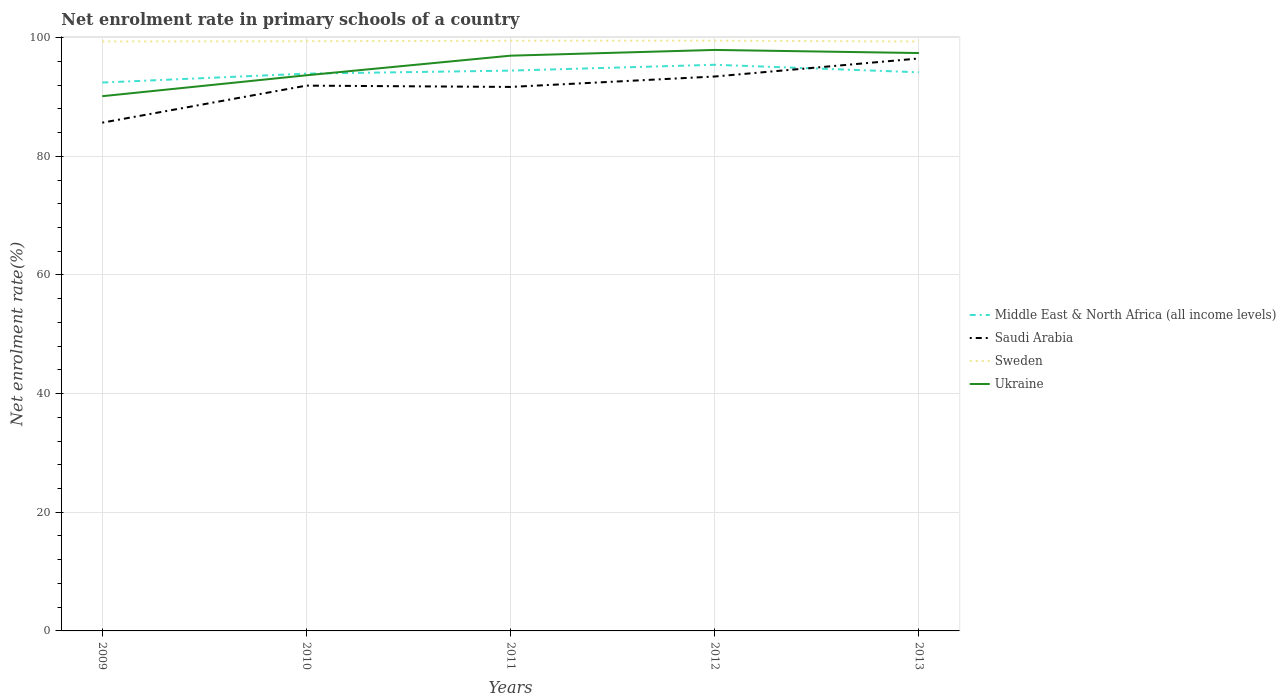Is the number of lines equal to the number of legend labels?
Provide a succinct answer. Yes. Across all years, what is the maximum net enrolment rate in primary schools in Sweden?
Your response must be concise. 99.34. What is the total net enrolment rate in primary schools in Sweden in the graph?
Make the answer very short. 0.01. What is the difference between the highest and the second highest net enrolment rate in primary schools in Middle East & North Africa (all income levels)?
Offer a very short reply. 3. What is the difference between the highest and the lowest net enrolment rate in primary schools in Ukraine?
Your answer should be compact. 3. How many lines are there?
Your response must be concise. 4. How many years are there in the graph?
Offer a terse response. 5. Does the graph contain any zero values?
Offer a terse response. No. How many legend labels are there?
Keep it short and to the point. 4. How are the legend labels stacked?
Make the answer very short. Vertical. What is the title of the graph?
Ensure brevity in your answer.  Net enrolment rate in primary schools of a country. What is the label or title of the Y-axis?
Give a very brief answer. Net enrolment rate(%). What is the Net enrolment rate(%) in Middle East & North Africa (all income levels) in 2009?
Make the answer very short. 92.43. What is the Net enrolment rate(%) of Saudi Arabia in 2009?
Your response must be concise. 85.67. What is the Net enrolment rate(%) of Sweden in 2009?
Offer a terse response. 99.35. What is the Net enrolment rate(%) in Ukraine in 2009?
Offer a terse response. 90.13. What is the Net enrolment rate(%) of Middle East & North Africa (all income levels) in 2010?
Provide a short and direct response. 93.93. What is the Net enrolment rate(%) of Saudi Arabia in 2010?
Your answer should be compact. 91.91. What is the Net enrolment rate(%) in Sweden in 2010?
Ensure brevity in your answer.  99.4. What is the Net enrolment rate(%) of Ukraine in 2010?
Your response must be concise. 93.65. What is the Net enrolment rate(%) of Middle East & North Africa (all income levels) in 2011?
Ensure brevity in your answer.  94.44. What is the Net enrolment rate(%) in Saudi Arabia in 2011?
Your answer should be compact. 91.69. What is the Net enrolment rate(%) of Sweden in 2011?
Make the answer very short. 99.47. What is the Net enrolment rate(%) of Ukraine in 2011?
Give a very brief answer. 96.96. What is the Net enrolment rate(%) of Middle East & North Africa (all income levels) in 2012?
Your answer should be very brief. 95.43. What is the Net enrolment rate(%) of Saudi Arabia in 2012?
Give a very brief answer. 93.45. What is the Net enrolment rate(%) in Sweden in 2012?
Ensure brevity in your answer.  99.49. What is the Net enrolment rate(%) in Ukraine in 2012?
Your answer should be compact. 97.93. What is the Net enrolment rate(%) of Middle East & North Africa (all income levels) in 2013?
Your response must be concise. 94.16. What is the Net enrolment rate(%) of Saudi Arabia in 2013?
Your answer should be compact. 96.49. What is the Net enrolment rate(%) of Sweden in 2013?
Offer a very short reply. 99.34. What is the Net enrolment rate(%) in Ukraine in 2013?
Give a very brief answer. 97.4. Across all years, what is the maximum Net enrolment rate(%) in Middle East & North Africa (all income levels)?
Your answer should be compact. 95.43. Across all years, what is the maximum Net enrolment rate(%) in Saudi Arabia?
Offer a very short reply. 96.49. Across all years, what is the maximum Net enrolment rate(%) of Sweden?
Provide a succinct answer. 99.49. Across all years, what is the maximum Net enrolment rate(%) of Ukraine?
Provide a short and direct response. 97.93. Across all years, what is the minimum Net enrolment rate(%) in Middle East & North Africa (all income levels)?
Offer a very short reply. 92.43. Across all years, what is the minimum Net enrolment rate(%) in Saudi Arabia?
Ensure brevity in your answer.  85.67. Across all years, what is the minimum Net enrolment rate(%) in Sweden?
Offer a very short reply. 99.34. Across all years, what is the minimum Net enrolment rate(%) of Ukraine?
Provide a succinct answer. 90.13. What is the total Net enrolment rate(%) in Middle East & North Africa (all income levels) in the graph?
Ensure brevity in your answer.  470.39. What is the total Net enrolment rate(%) of Saudi Arabia in the graph?
Keep it short and to the point. 459.2. What is the total Net enrolment rate(%) in Sweden in the graph?
Provide a succinct answer. 497.05. What is the total Net enrolment rate(%) in Ukraine in the graph?
Your answer should be compact. 476.07. What is the difference between the Net enrolment rate(%) in Middle East & North Africa (all income levels) in 2009 and that in 2010?
Give a very brief answer. -1.5. What is the difference between the Net enrolment rate(%) of Saudi Arabia in 2009 and that in 2010?
Give a very brief answer. -6.24. What is the difference between the Net enrolment rate(%) of Sweden in 2009 and that in 2010?
Ensure brevity in your answer.  -0.05. What is the difference between the Net enrolment rate(%) in Ukraine in 2009 and that in 2010?
Your answer should be compact. -3.52. What is the difference between the Net enrolment rate(%) of Middle East & North Africa (all income levels) in 2009 and that in 2011?
Ensure brevity in your answer.  -2.01. What is the difference between the Net enrolment rate(%) of Saudi Arabia in 2009 and that in 2011?
Give a very brief answer. -6.02. What is the difference between the Net enrolment rate(%) of Sweden in 2009 and that in 2011?
Keep it short and to the point. -0.12. What is the difference between the Net enrolment rate(%) of Ukraine in 2009 and that in 2011?
Your response must be concise. -6.83. What is the difference between the Net enrolment rate(%) in Middle East & North Africa (all income levels) in 2009 and that in 2012?
Give a very brief answer. -3. What is the difference between the Net enrolment rate(%) in Saudi Arabia in 2009 and that in 2012?
Offer a terse response. -7.78. What is the difference between the Net enrolment rate(%) in Sweden in 2009 and that in 2012?
Your answer should be compact. -0.14. What is the difference between the Net enrolment rate(%) in Ukraine in 2009 and that in 2012?
Offer a terse response. -7.8. What is the difference between the Net enrolment rate(%) in Middle East & North Africa (all income levels) in 2009 and that in 2013?
Give a very brief answer. -1.73. What is the difference between the Net enrolment rate(%) of Saudi Arabia in 2009 and that in 2013?
Your answer should be compact. -10.82. What is the difference between the Net enrolment rate(%) in Sweden in 2009 and that in 2013?
Make the answer very short. 0.01. What is the difference between the Net enrolment rate(%) of Ukraine in 2009 and that in 2013?
Your answer should be compact. -7.27. What is the difference between the Net enrolment rate(%) in Middle East & North Africa (all income levels) in 2010 and that in 2011?
Your answer should be very brief. -0.51. What is the difference between the Net enrolment rate(%) of Saudi Arabia in 2010 and that in 2011?
Make the answer very short. 0.22. What is the difference between the Net enrolment rate(%) of Sweden in 2010 and that in 2011?
Your answer should be compact. -0.08. What is the difference between the Net enrolment rate(%) in Ukraine in 2010 and that in 2011?
Offer a terse response. -3.3. What is the difference between the Net enrolment rate(%) in Middle East & North Africa (all income levels) in 2010 and that in 2012?
Ensure brevity in your answer.  -1.49. What is the difference between the Net enrolment rate(%) of Saudi Arabia in 2010 and that in 2012?
Your answer should be very brief. -1.54. What is the difference between the Net enrolment rate(%) in Sweden in 2010 and that in 2012?
Provide a short and direct response. -0.09. What is the difference between the Net enrolment rate(%) in Ukraine in 2010 and that in 2012?
Offer a terse response. -4.27. What is the difference between the Net enrolment rate(%) in Middle East & North Africa (all income levels) in 2010 and that in 2013?
Ensure brevity in your answer.  -0.23. What is the difference between the Net enrolment rate(%) in Saudi Arabia in 2010 and that in 2013?
Offer a very short reply. -4.58. What is the difference between the Net enrolment rate(%) of Sweden in 2010 and that in 2013?
Your answer should be compact. 0.05. What is the difference between the Net enrolment rate(%) of Ukraine in 2010 and that in 2013?
Your response must be concise. -3.75. What is the difference between the Net enrolment rate(%) of Middle East & North Africa (all income levels) in 2011 and that in 2012?
Your answer should be compact. -0.98. What is the difference between the Net enrolment rate(%) of Saudi Arabia in 2011 and that in 2012?
Provide a succinct answer. -1.76. What is the difference between the Net enrolment rate(%) of Sweden in 2011 and that in 2012?
Make the answer very short. -0.01. What is the difference between the Net enrolment rate(%) of Ukraine in 2011 and that in 2012?
Make the answer very short. -0.97. What is the difference between the Net enrolment rate(%) of Middle East & North Africa (all income levels) in 2011 and that in 2013?
Your answer should be very brief. 0.28. What is the difference between the Net enrolment rate(%) of Saudi Arabia in 2011 and that in 2013?
Keep it short and to the point. -4.8. What is the difference between the Net enrolment rate(%) of Sweden in 2011 and that in 2013?
Your answer should be compact. 0.13. What is the difference between the Net enrolment rate(%) in Ukraine in 2011 and that in 2013?
Make the answer very short. -0.44. What is the difference between the Net enrolment rate(%) of Middle East & North Africa (all income levels) in 2012 and that in 2013?
Give a very brief answer. 1.27. What is the difference between the Net enrolment rate(%) of Saudi Arabia in 2012 and that in 2013?
Your answer should be compact. -3.04. What is the difference between the Net enrolment rate(%) in Sweden in 2012 and that in 2013?
Your response must be concise. 0.14. What is the difference between the Net enrolment rate(%) of Ukraine in 2012 and that in 2013?
Your answer should be very brief. 0.52. What is the difference between the Net enrolment rate(%) of Middle East & North Africa (all income levels) in 2009 and the Net enrolment rate(%) of Saudi Arabia in 2010?
Offer a very short reply. 0.52. What is the difference between the Net enrolment rate(%) of Middle East & North Africa (all income levels) in 2009 and the Net enrolment rate(%) of Sweden in 2010?
Provide a succinct answer. -6.97. What is the difference between the Net enrolment rate(%) in Middle East & North Africa (all income levels) in 2009 and the Net enrolment rate(%) in Ukraine in 2010?
Provide a short and direct response. -1.23. What is the difference between the Net enrolment rate(%) in Saudi Arabia in 2009 and the Net enrolment rate(%) in Sweden in 2010?
Make the answer very short. -13.73. What is the difference between the Net enrolment rate(%) in Saudi Arabia in 2009 and the Net enrolment rate(%) in Ukraine in 2010?
Your response must be concise. -7.99. What is the difference between the Net enrolment rate(%) in Sweden in 2009 and the Net enrolment rate(%) in Ukraine in 2010?
Ensure brevity in your answer.  5.7. What is the difference between the Net enrolment rate(%) of Middle East & North Africa (all income levels) in 2009 and the Net enrolment rate(%) of Saudi Arabia in 2011?
Your answer should be compact. 0.74. What is the difference between the Net enrolment rate(%) in Middle East & North Africa (all income levels) in 2009 and the Net enrolment rate(%) in Sweden in 2011?
Provide a short and direct response. -7.04. What is the difference between the Net enrolment rate(%) in Middle East & North Africa (all income levels) in 2009 and the Net enrolment rate(%) in Ukraine in 2011?
Keep it short and to the point. -4.53. What is the difference between the Net enrolment rate(%) in Saudi Arabia in 2009 and the Net enrolment rate(%) in Sweden in 2011?
Offer a very short reply. -13.81. What is the difference between the Net enrolment rate(%) of Saudi Arabia in 2009 and the Net enrolment rate(%) of Ukraine in 2011?
Provide a succinct answer. -11.29. What is the difference between the Net enrolment rate(%) in Sweden in 2009 and the Net enrolment rate(%) in Ukraine in 2011?
Make the answer very short. 2.39. What is the difference between the Net enrolment rate(%) in Middle East & North Africa (all income levels) in 2009 and the Net enrolment rate(%) in Saudi Arabia in 2012?
Your answer should be very brief. -1.02. What is the difference between the Net enrolment rate(%) of Middle East & North Africa (all income levels) in 2009 and the Net enrolment rate(%) of Sweden in 2012?
Your response must be concise. -7.06. What is the difference between the Net enrolment rate(%) in Middle East & North Africa (all income levels) in 2009 and the Net enrolment rate(%) in Ukraine in 2012?
Give a very brief answer. -5.5. What is the difference between the Net enrolment rate(%) of Saudi Arabia in 2009 and the Net enrolment rate(%) of Sweden in 2012?
Keep it short and to the point. -13.82. What is the difference between the Net enrolment rate(%) of Saudi Arabia in 2009 and the Net enrolment rate(%) of Ukraine in 2012?
Ensure brevity in your answer.  -12.26. What is the difference between the Net enrolment rate(%) in Sweden in 2009 and the Net enrolment rate(%) in Ukraine in 2012?
Keep it short and to the point. 1.42. What is the difference between the Net enrolment rate(%) in Middle East & North Africa (all income levels) in 2009 and the Net enrolment rate(%) in Saudi Arabia in 2013?
Make the answer very short. -4.06. What is the difference between the Net enrolment rate(%) in Middle East & North Africa (all income levels) in 2009 and the Net enrolment rate(%) in Sweden in 2013?
Keep it short and to the point. -6.92. What is the difference between the Net enrolment rate(%) of Middle East & North Africa (all income levels) in 2009 and the Net enrolment rate(%) of Ukraine in 2013?
Offer a terse response. -4.97. What is the difference between the Net enrolment rate(%) of Saudi Arabia in 2009 and the Net enrolment rate(%) of Sweden in 2013?
Offer a very short reply. -13.68. What is the difference between the Net enrolment rate(%) of Saudi Arabia in 2009 and the Net enrolment rate(%) of Ukraine in 2013?
Your answer should be compact. -11.74. What is the difference between the Net enrolment rate(%) in Sweden in 2009 and the Net enrolment rate(%) in Ukraine in 2013?
Your response must be concise. 1.95. What is the difference between the Net enrolment rate(%) in Middle East & North Africa (all income levels) in 2010 and the Net enrolment rate(%) in Saudi Arabia in 2011?
Offer a very short reply. 2.24. What is the difference between the Net enrolment rate(%) in Middle East & North Africa (all income levels) in 2010 and the Net enrolment rate(%) in Sweden in 2011?
Provide a succinct answer. -5.54. What is the difference between the Net enrolment rate(%) of Middle East & North Africa (all income levels) in 2010 and the Net enrolment rate(%) of Ukraine in 2011?
Keep it short and to the point. -3.03. What is the difference between the Net enrolment rate(%) in Saudi Arabia in 2010 and the Net enrolment rate(%) in Sweden in 2011?
Your response must be concise. -7.56. What is the difference between the Net enrolment rate(%) in Saudi Arabia in 2010 and the Net enrolment rate(%) in Ukraine in 2011?
Your answer should be very brief. -5.05. What is the difference between the Net enrolment rate(%) in Sweden in 2010 and the Net enrolment rate(%) in Ukraine in 2011?
Make the answer very short. 2.44. What is the difference between the Net enrolment rate(%) of Middle East & North Africa (all income levels) in 2010 and the Net enrolment rate(%) of Saudi Arabia in 2012?
Offer a terse response. 0.49. What is the difference between the Net enrolment rate(%) of Middle East & North Africa (all income levels) in 2010 and the Net enrolment rate(%) of Sweden in 2012?
Your answer should be compact. -5.55. What is the difference between the Net enrolment rate(%) of Middle East & North Africa (all income levels) in 2010 and the Net enrolment rate(%) of Ukraine in 2012?
Provide a short and direct response. -3.99. What is the difference between the Net enrolment rate(%) of Saudi Arabia in 2010 and the Net enrolment rate(%) of Sweden in 2012?
Give a very brief answer. -7.58. What is the difference between the Net enrolment rate(%) of Saudi Arabia in 2010 and the Net enrolment rate(%) of Ukraine in 2012?
Make the answer very short. -6.02. What is the difference between the Net enrolment rate(%) in Sweden in 2010 and the Net enrolment rate(%) in Ukraine in 2012?
Make the answer very short. 1.47. What is the difference between the Net enrolment rate(%) in Middle East & North Africa (all income levels) in 2010 and the Net enrolment rate(%) in Saudi Arabia in 2013?
Keep it short and to the point. -2.55. What is the difference between the Net enrolment rate(%) in Middle East & North Africa (all income levels) in 2010 and the Net enrolment rate(%) in Sweden in 2013?
Provide a short and direct response. -5.41. What is the difference between the Net enrolment rate(%) in Middle East & North Africa (all income levels) in 2010 and the Net enrolment rate(%) in Ukraine in 2013?
Provide a succinct answer. -3.47. What is the difference between the Net enrolment rate(%) in Saudi Arabia in 2010 and the Net enrolment rate(%) in Sweden in 2013?
Provide a succinct answer. -7.43. What is the difference between the Net enrolment rate(%) of Saudi Arabia in 2010 and the Net enrolment rate(%) of Ukraine in 2013?
Provide a succinct answer. -5.49. What is the difference between the Net enrolment rate(%) in Sweden in 2010 and the Net enrolment rate(%) in Ukraine in 2013?
Provide a short and direct response. 1.99. What is the difference between the Net enrolment rate(%) in Middle East & North Africa (all income levels) in 2011 and the Net enrolment rate(%) in Sweden in 2012?
Give a very brief answer. -5.05. What is the difference between the Net enrolment rate(%) of Middle East & North Africa (all income levels) in 2011 and the Net enrolment rate(%) of Ukraine in 2012?
Provide a succinct answer. -3.48. What is the difference between the Net enrolment rate(%) of Saudi Arabia in 2011 and the Net enrolment rate(%) of Sweden in 2012?
Your answer should be very brief. -7.8. What is the difference between the Net enrolment rate(%) of Saudi Arabia in 2011 and the Net enrolment rate(%) of Ukraine in 2012?
Offer a terse response. -6.24. What is the difference between the Net enrolment rate(%) of Sweden in 2011 and the Net enrolment rate(%) of Ukraine in 2012?
Give a very brief answer. 1.55. What is the difference between the Net enrolment rate(%) of Middle East & North Africa (all income levels) in 2011 and the Net enrolment rate(%) of Saudi Arabia in 2013?
Your answer should be very brief. -2.04. What is the difference between the Net enrolment rate(%) of Middle East & North Africa (all income levels) in 2011 and the Net enrolment rate(%) of Sweden in 2013?
Ensure brevity in your answer.  -4.9. What is the difference between the Net enrolment rate(%) in Middle East & North Africa (all income levels) in 2011 and the Net enrolment rate(%) in Ukraine in 2013?
Offer a very short reply. -2.96. What is the difference between the Net enrolment rate(%) in Saudi Arabia in 2011 and the Net enrolment rate(%) in Sweden in 2013?
Provide a short and direct response. -7.65. What is the difference between the Net enrolment rate(%) in Saudi Arabia in 2011 and the Net enrolment rate(%) in Ukraine in 2013?
Keep it short and to the point. -5.71. What is the difference between the Net enrolment rate(%) of Sweden in 2011 and the Net enrolment rate(%) of Ukraine in 2013?
Your response must be concise. 2.07. What is the difference between the Net enrolment rate(%) in Middle East & North Africa (all income levels) in 2012 and the Net enrolment rate(%) in Saudi Arabia in 2013?
Offer a very short reply. -1.06. What is the difference between the Net enrolment rate(%) in Middle East & North Africa (all income levels) in 2012 and the Net enrolment rate(%) in Sweden in 2013?
Your answer should be compact. -3.92. What is the difference between the Net enrolment rate(%) in Middle East & North Africa (all income levels) in 2012 and the Net enrolment rate(%) in Ukraine in 2013?
Ensure brevity in your answer.  -1.98. What is the difference between the Net enrolment rate(%) in Saudi Arabia in 2012 and the Net enrolment rate(%) in Sweden in 2013?
Offer a very short reply. -5.9. What is the difference between the Net enrolment rate(%) in Saudi Arabia in 2012 and the Net enrolment rate(%) in Ukraine in 2013?
Keep it short and to the point. -3.96. What is the difference between the Net enrolment rate(%) of Sweden in 2012 and the Net enrolment rate(%) of Ukraine in 2013?
Ensure brevity in your answer.  2.08. What is the average Net enrolment rate(%) in Middle East & North Africa (all income levels) per year?
Keep it short and to the point. 94.08. What is the average Net enrolment rate(%) of Saudi Arabia per year?
Keep it short and to the point. 91.84. What is the average Net enrolment rate(%) in Sweden per year?
Offer a very short reply. 99.41. What is the average Net enrolment rate(%) of Ukraine per year?
Offer a terse response. 95.21. In the year 2009, what is the difference between the Net enrolment rate(%) in Middle East & North Africa (all income levels) and Net enrolment rate(%) in Saudi Arabia?
Your answer should be compact. 6.76. In the year 2009, what is the difference between the Net enrolment rate(%) of Middle East & North Africa (all income levels) and Net enrolment rate(%) of Sweden?
Make the answer very short. -6.92. In the year 2009, what is the difference between the Net enrolment rate(%) of Middle East & North Africa (all income levels) and Net enrolment rate(%) of Ukraine?
Your response must be concise. 2.3. In the year 2009, what is the difference between the Net enrolment rate(%) in Saudi Arabia and Net enrolment rate(%) in Sweden?
Your answer should be very brief. -13.68. In the year 2009, what is the difference between the Net enrolment rate(%) in Saudi Arabia and Net enrolment rate(%) in Ukraine?
Ensure brevity in your answer.  -4.46. In the year 2009, what is the difference between the Net enrolment rate(%) in Sweden and Net enrolment rate(%) in Ukraine?
Make the answer very short. 9.22. In the year 2010, what is the difference between the Net enrolment rate(%) of Middle East & North Africa (all income levels) and Net enrolment rate(%) of Saudi Arabia?
Ensure brevity in your answer.  2.02. In the year 2010, what is the difference between the Net enrolment rate(%) of Middle East & North Africa (all income levels) and Net enrolment rate(%) of Sweden?
Your answer should be compact. -5.46. In the year 2010, what is the difference between the Net enrolment rate(%) in Middle East & North Africa (all income levels) and Net enrolment rate(%) in Ukraine?
Provide a succinct answer. 0.28. In the year 2010, what is the difference between the Net enrolment rate(%) of Saudi Arabia and Net enrolment rate(%) of Sweden?
Provide a succinct answer. -7.49. In the year 2010, what is the difference between the Net enrolment rate(%) in Saudi Arabia and Net enrolment rate(%) in Ukraine?
Give a very brief answer. -1.74. In the year 2010, what is the difference between the Net enrolment rate(%) of Sweden and Net enrolment rate(%) of Ukraine?
Ensure brevity in your answer.  5.74. In the year 2011, what is the difference between the Net enrolment rate(%) in Middle East & North Africa (all income levels) and Net enrolment rate(%) in Saudi Arabia?
Offer a very short reply. 2.75. In the year 2011, what is the difference between the Net enrolment rate(%) of Middle East & North Africa (all income levels) and Net enrolment rate(%) of Sweden?
Your answer should be compact. -5.03. In the year 2011, what is the difference between the Net enrolment rate(%) in Middle East & North Africa (all income levels) and Net enrolment rate(%) in Ukraine?
Offer a terse response. -2.52. In the year 2011, what is the difference between the Net enrolment rate(%) in Saudi Arabia and Net enrolment rate(%) in Sweden?
Your answer should be compact. -7.78. In the year 2011, what is the difference between the Net enrolment rate(%) of Saudi Arabia and Net enrolment rate(%) of Ukraine?
Provide a short and direct response. -5.27. In the year 2011, what is the difference between the Net enrolment rate(%) in Sweden and Net enrolment rate(%) in Ukraine?
Provide a succinct answer. 2.51. In the year 2012, what is the difference between the Net enrolment rate(%) of Middle East & North Africa (all income levels) and Net enrolment rate(%) of Saudi Arabia?
Offer a terse response. 1.98. In the year 2012, what is the difference between the Net enrolment rate(%) of Middle East & North Africa (all income levels) and Net enrolment rate(%) of Sweden?
Provide a short and direct response. -4.06. In the year 2012, what is the difference between the Net enrolment rate(%) in Middle East & North Africa (all income levels) and Net enrolment rate(%) in Ukraine?
Offer a very short reply. -2.5. In the year 2012, what is the difference between the Net enrolment rate(%) in Saudi Arabia and Net enrolment rate(%) in Sweden?
Provide a short and direct response. -6.04. In the year 2012, what is the difference between the Net enrolment rate(%) in Saudi Arabia and Net enrolment rate(%) in Ukraine?
Your answer should be very brief. -4.48. In the year 2012, what is the difference between the Net enrolment rate(%) in Sweden and Net enrolment rate(%) in Ukraine?
Your answer should be compact. 1.56. In the year 2013, what is the difference between the Net enrolment rate(%) in Middle East & North Africa (all income levels) and Net enrolment rate(%) in Saudi Arabia?
Your response must be concise. -2.33. In the year 2013, what is the difference between the Net enrolment rate(%) in Middle East & North Africa (all income levels) and Net enrolment rate(%) in Sweden?
Your answer should be very brief. -5.19. In the year 2013, what is the difference between the Net enrolment rate(%) in Middle East & North Africa (all income levels) and Net enrolment rate(%) in Ukraine?
Offer a terse response. -3.24. In the year 2013, what is the difference between the Net enrolment rate(%) in Saudi Arabia and Net enrolment rate(%) in Sweden?
Provide a succinct answer. -2.86. In the year 2013, what is the difference between the Net enrolment rate(%) in Saudi Arabia and Net enrolment rate(%) in Ukraine?
Offer a terse response. -0.92. In the year 2013, what is the difference between the Net enrolment rate(%) of Sweden and Net enrolment rate(%) of Ukraine?
Your answer should be very brief. 1.94. What is the ratio of the Net enrolment rate(%) of Saudi Arabia in 2009 to that in 2010?
Give a very brief answer. 0.93. What is the ratio of the Net enrolment rate(%) in Ukraine in 2009 to that in 2010?
Ensure brevity in your answer.  0.96. What is the ratio of the Net enrolment rate(%) in Middle East & North Africa (all income levels) in 2009 to that in 2011?
Make the answer very short. 0.98. What is the ratio of the Net enrolment rate(%) in Saudi Arabia in 2009 to that in 2011?
Your answer should be very brief. 0.93. What is the ratio of the Net enrolment rate(%) of Ukraine in 2009 to that in 2011?
Provide a short and direct response. 0.93. What is the ratio of the Net enrolment rate(%) in Middle East & North Africa (all income levels) in 2009 to that in 2012?
Your response must be concise. 0.97. What is the ratio of the Net enrolment rate(%) of Saudi Arabia in 2009 to that in 2012?
Your response must be concise. 0.92. What is the ratio of the Net enrolment rate(%) in Sweden in 2009 to that in 2012?
Provide a succinct answer. 1. What is the ratio of the Net enrolment rate(%) in Ukraine in 2009 to that in 2012?
Your response must be concise. 0.92. What is the ratio of the Net enrolment rate(%) in Middle East & North Africa (all income levels) in 2009 to that in 2013?
Offer a very short reply. 0.98. What is the ratio of the Net enrolment rate(%) in Saudi Arabia in 2009 to that in 2013?
Give a very brief answer. 0.89. What is the ratio of the Net enrolment rate(%) in Ukraine in 2009 to that in 2013?
Provide a short and direct response. 0.93. What is the ratio of the Net enrolment rate(%) in Middle East & North Africa (all income levels) in 2010 to that in 2011?
Ensure brevity in your answer.  0.99. What is the ratio of the Net enrolment rate(%) in Sweden in 2010 to that in 2011?
Offer a very short reply. 1. What is the ratio of the Net enrolment rate(%) in Ukraine in 2010 to that in 2011?
Provide a succinct answer. 0.97. What is the ratio of the Net enrolment rate(%) of Middle East & North Africa (all income levels) in 2010 to that in 2012?
Offer a terse response. 0.98. What is the ratio of the Net enrolment rate(%) of Saudi Arabia in 2010 to that in 2012?
Make the answer very short. 0.98. What is the ratio of the Net enrolment rate(%) of Sweden in 2010 to that in 2012?
Offer a very short reply. 1. What is the ratio of the Net enrolment rate(%) in Ukraine in 2010 to that in 2012?
Offer a very short reply. 0.96. What is the ratio of the Net enrolment rate(%) of Saudi Arabia in 2010 to that in 2013?
Your response must be concise. 0.95. What is the ratio of the Net enrolment rate(%) of Sweden in 2010 to that in 2013?
Your answer should be compact. 1. What is the ratio of the Net enrolment rate(%) of Ukraine in 2010 to that in 2013?
Your answer should be compact. 0.96. What is the ratio of the Net enrolment rate(%) of Saudi Arabia in 2011 to that in 2012?
Your response must be concise. 0.98. What is the ratio of the Net enrolment rate(%) in Saudi Arabia in 2011 to that in 2013?
Ensure brevity in your answer.  0.95. What is the ratio of the Net enrolment rate(%) of Ukraine in 2011 to that in 2013?
Your answer should be compact. 1. What is the ratio of the Net enrolment rate(%) in Middle East & North Africa (all income levels) in 2012 to that in 2013?
Give a very brief answer. 1.01. What is the ratio of the Net enrolment rate(%) in Saudi Arabia in 2012 to that in 2013?
Ensure brevity in your answer.  0.97. What is the ratio of the Net enrolment rate(%) in Sweden in 2012 to that in 2013?
Offer a terse response. 1. What is the ratio of the Net enrolment rate(%) of Ukraine in 2012 to that in 2013?
Ensure brevity in your answer.  1.01. What is the difference between the highest and the second highest Net enrolment rate(%) in Middle East & North Africa (all income levels)?
Make the answer very short. 0.98. What is the difference between the highest and the second highest Net enrolment rate(%) of Saudi Arabia?
Your response must be concise. 3.04. What is the difference between the highest and the second highest Net enrolment rate(%) in Sweden?
Your response must be concise. 0.01. What is the difference between the highest and the second highest Net enrolment rate(%) of Ukraine?
Keep it short and to the point. 0.52. What is the difference between the highest and the lowest Net enrolment rate(%) in Middle East & North Africa (all income levels)?
Offer a very short reply. 3. What is the difference between the highest and the lowest Net enrolment rate(%) in Saudi Arabia?
Your answer should be compact. 10.82. What is the difference between the highest and the lowest Net enrolment rate(%) in Sweden?
Your answer should be compact. 0.14. What is the difference between the highest and the lowest Net enrolment rate(%) of Ukraine?
Provide a succinct answer. 7.8. 